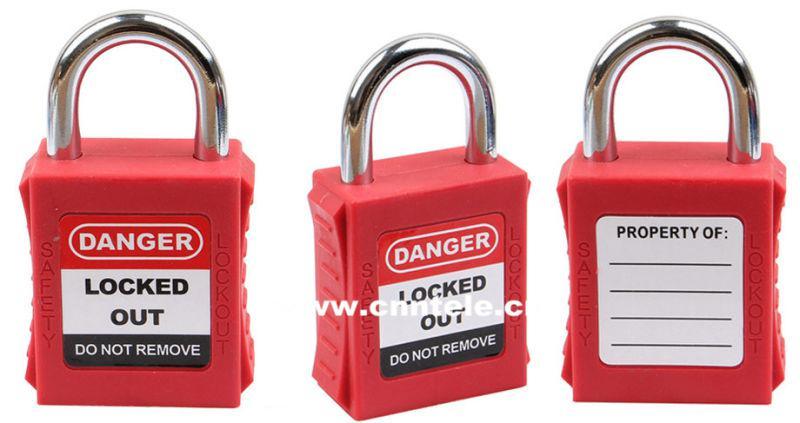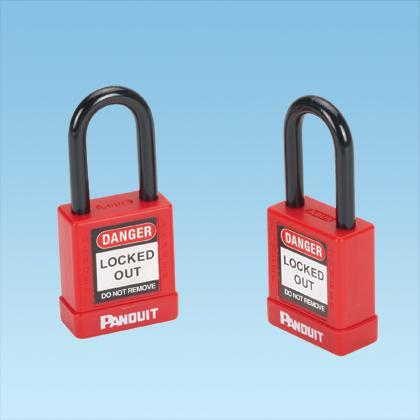The first image is the image on the left, the second image is the image on the right. Examine the images to the left and right. Is the description "One of the locks on the left is black." accurate? Answer yes or no. No. 